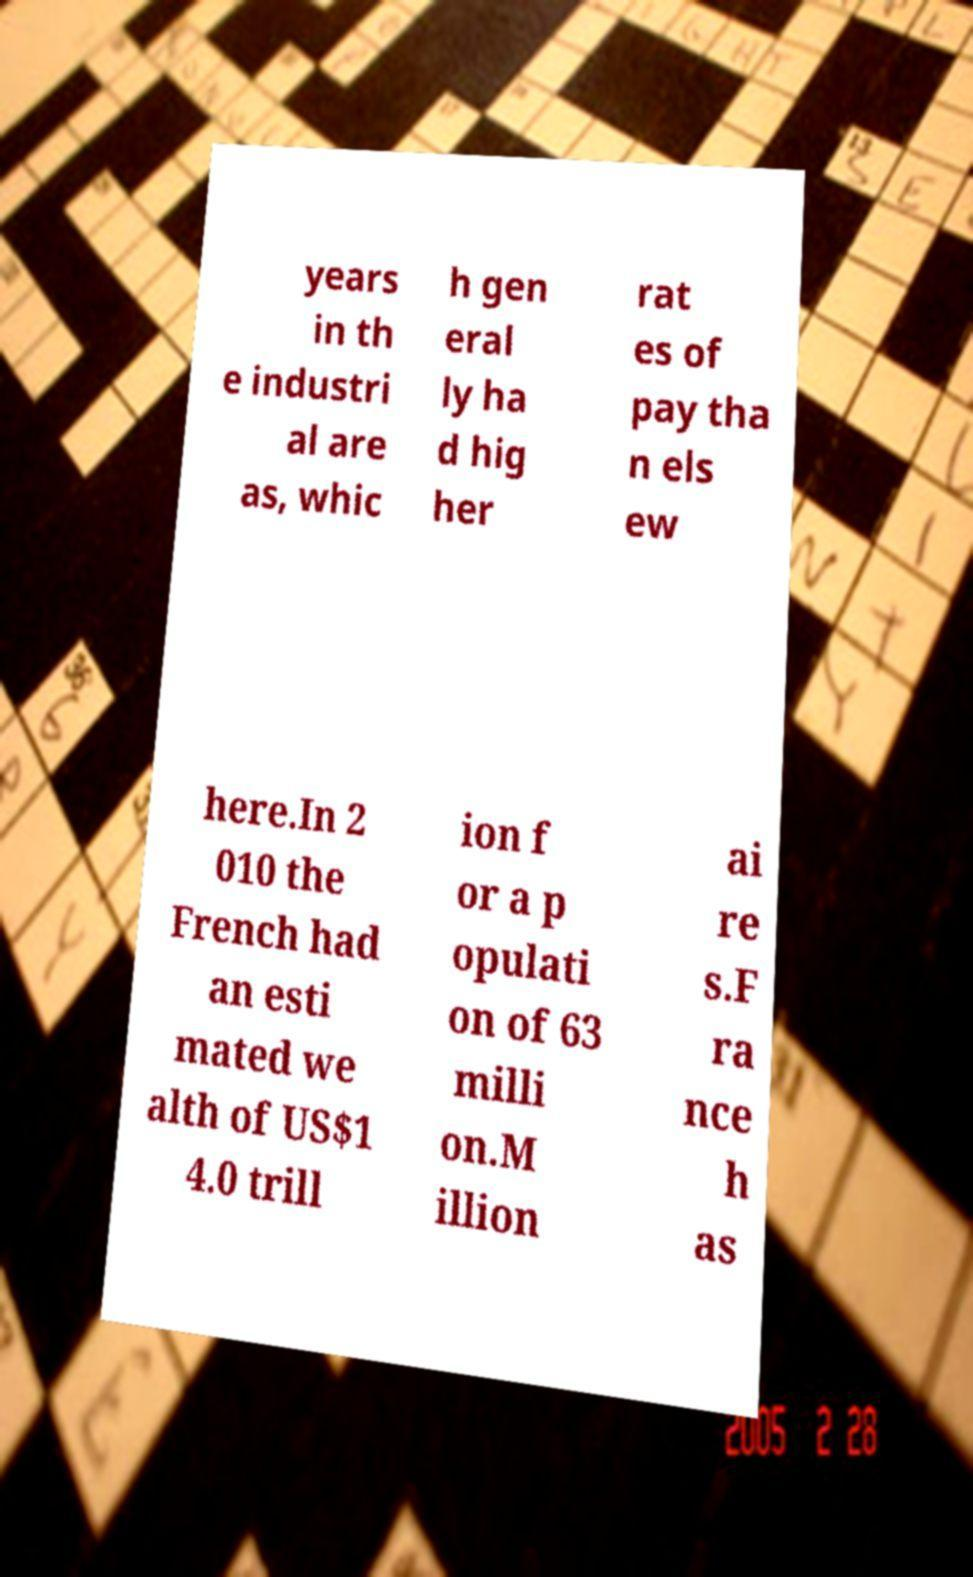Please identify and transcribe the text found in this image. years in th e industri al are as, whic h gen eral ly ha d hig her rat es of pay tha n els ew here.In 2 010 the French had an esti mated we alth of US$1 4.0 trill ion f or a p opulati on of 63 milli on.M illion ai re s.F ra nce h as 